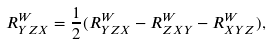Convert formula to latex. <formula><loc_0><loc_0><loc_500><loc_500>R _ { Y Z X } ^ { W } = \frac { 1 } { 2 } ( R _ { Y Z X } ^ { W } - R _ { Z X Y } ^ { W } - R _ { X Y Z } ^ { W } ) ,</formula> 